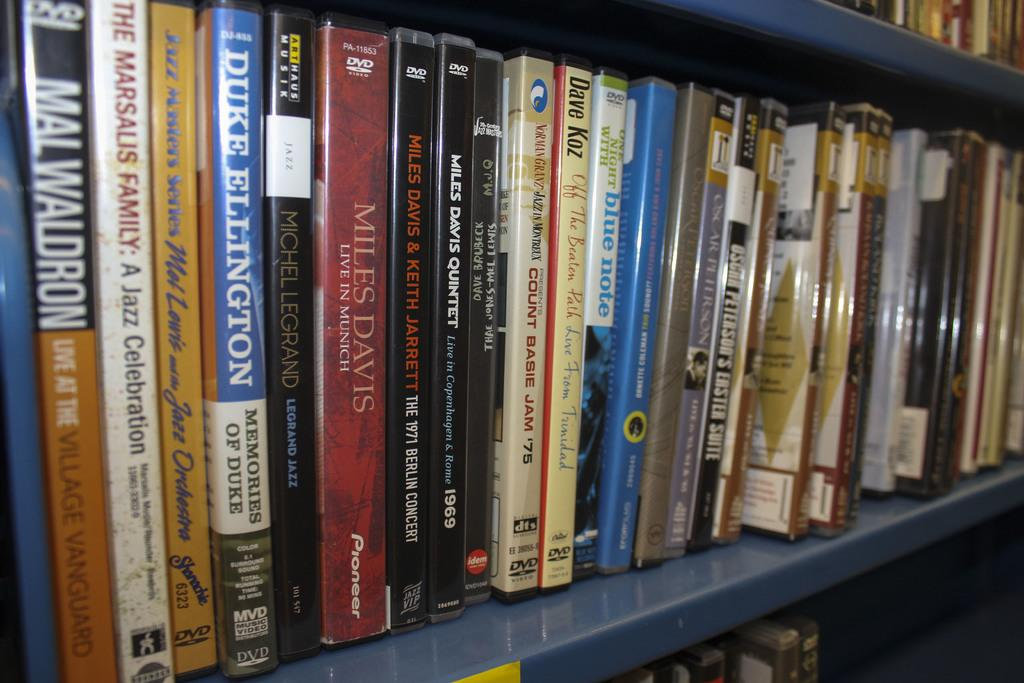<image>
Describe the image concisely. the word miles is on the red book 